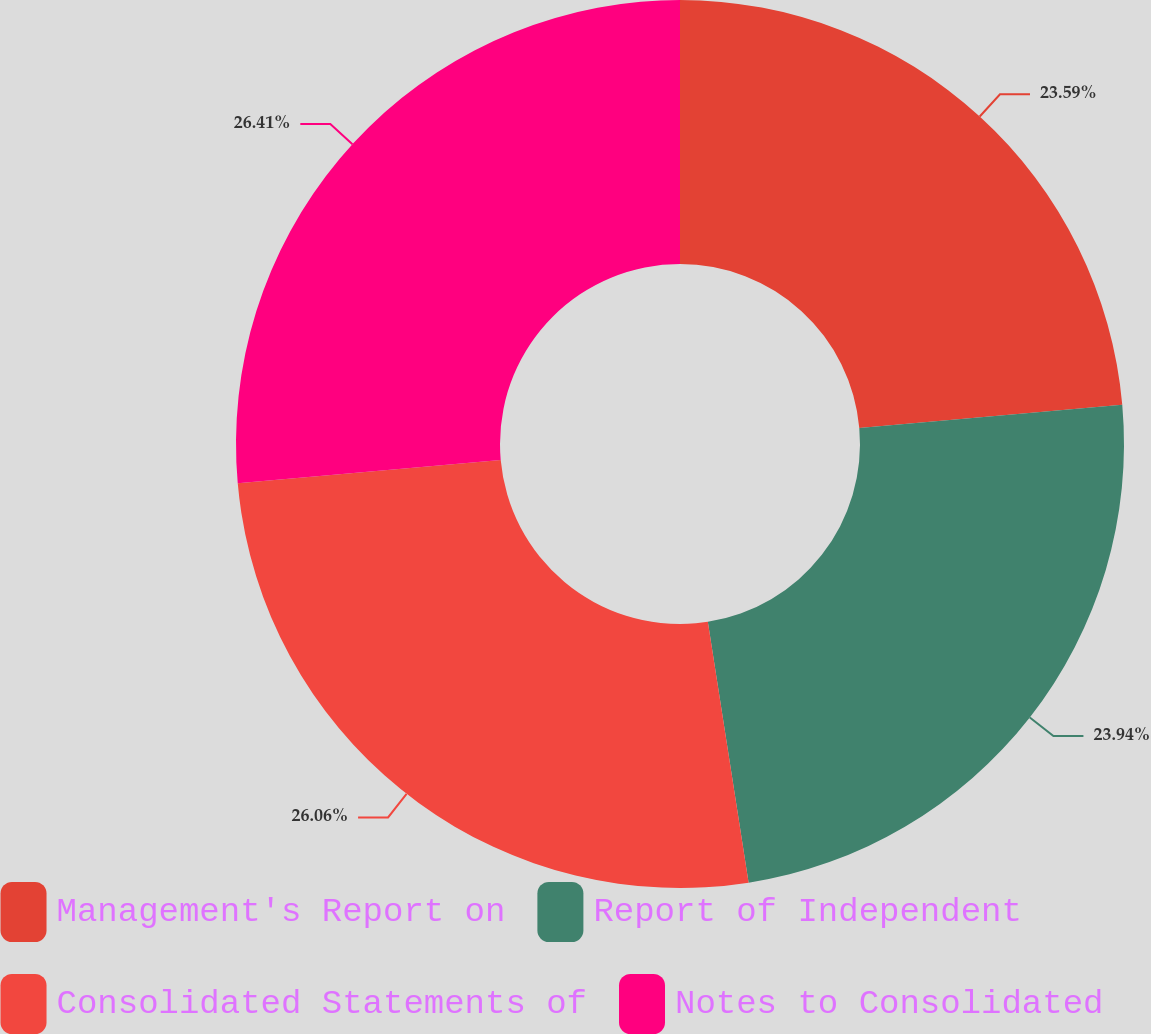Convert chart. <chart><loc_0><loc_0><loc_500><loc_500><pie_chart><fcel>Management's Report on<fcel>Report of Independent<fcel>Consolidated Statements of<fcel>Notes to Consolidated<nl><fcel>23.59%<fcel>23.94%<fcel>26.06%<fcel>26.41%<nl></chart> 